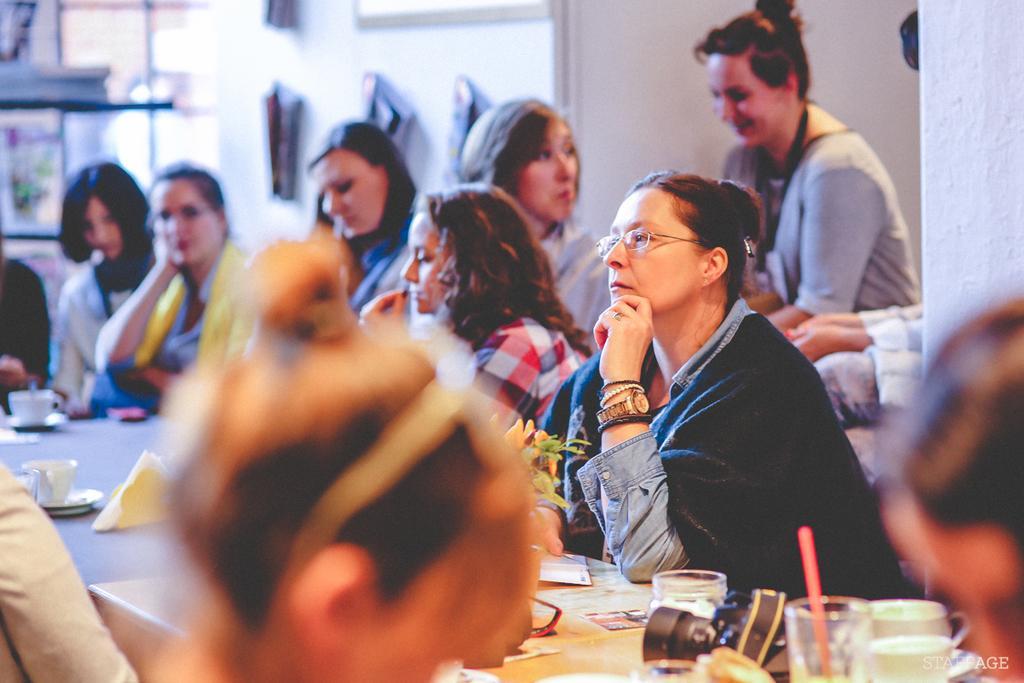In one or two sentences, can you explain what this image depicts? A group of women are sitting at a table. 